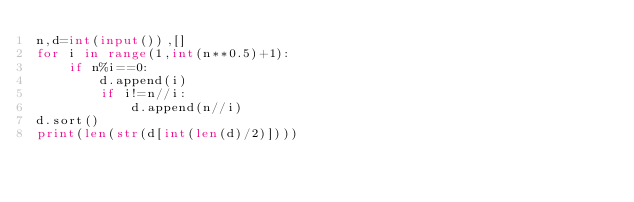Convert code to text. <code><loc_0><loc_0><loc_500><loc_500><_Python_>n,d=int(input()),[]
for i in range(1,int(n**0.5)+1):
    if n%i==0:
        d.append(i)
        if i!=n//i:
            d.append(n//i)
d.sort()
print(len(str(d[int(len(d)/2)])))</code> 